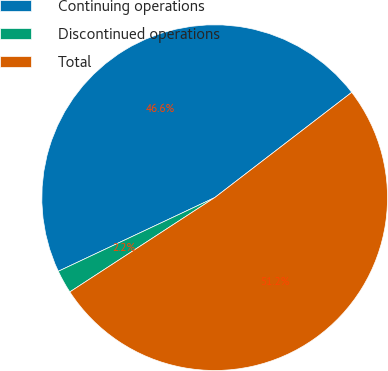<chart> <loc_0><loc_0><loc_500><loc_500><pie_chart><fcel>Continuing operations<fcel>Discontinued operations<fcel>Total<nl><fcel>46.58%<fcel>2.18%<fcel>51.24%<nl></chart> 